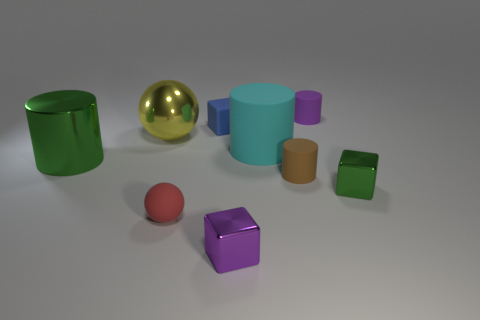Add 1 brown metal things. How many objects exist? 10 Subtract all cylinders. How many objects are left? 5 Add 9 rubber spheres. How many rubber spheres exist? 10 Subtract 0 gray spheres. How many objects are left? 9 Subtract all red things. Subtract all cyan cylinders. How many objects are left? 7 Add 1 small purple metal cubes. How many small purple metal cubes are left? 2 